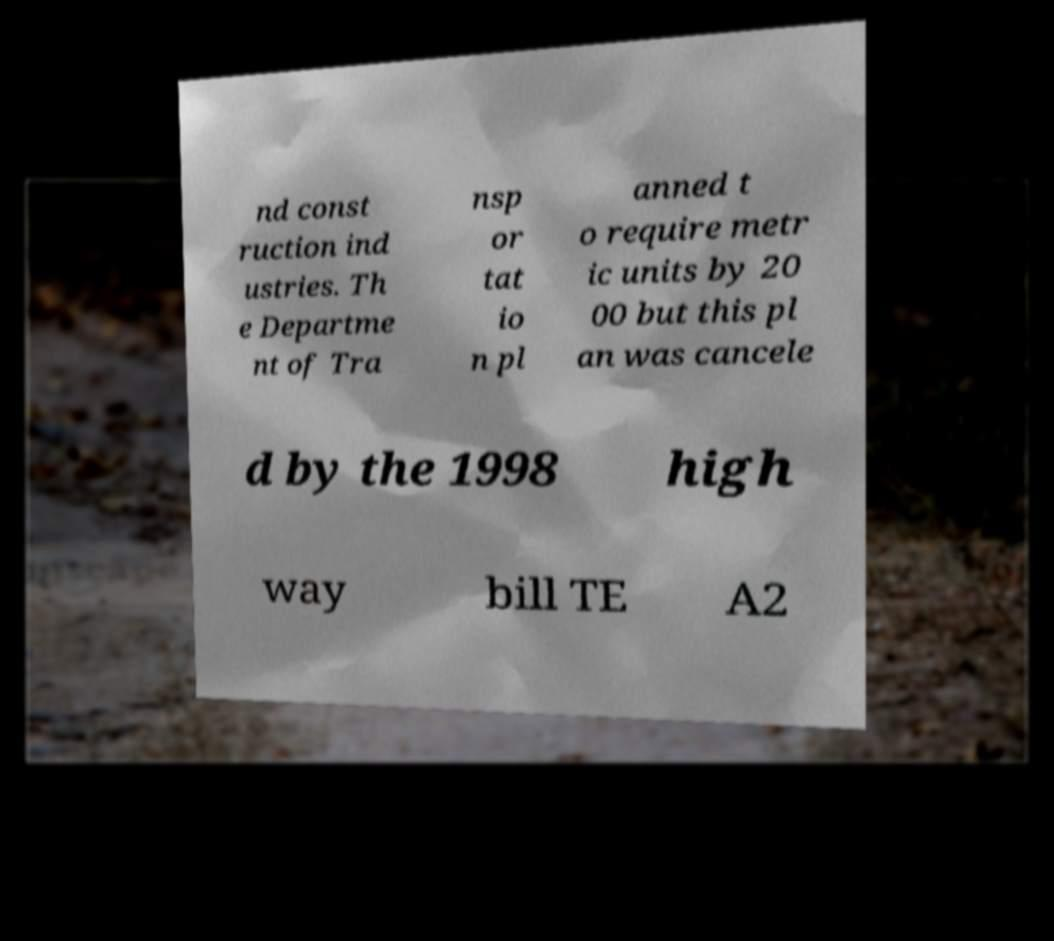There's text embedded in this image that I need extracted. Can you transcribe it verbatim? nd const ruction ind ustries. Th e Departme nt of Tra nsp or tat io n pl anned t o require metr ic units by 20 00 but this pl an was cancele d by the 1998 high way bill TE A2 